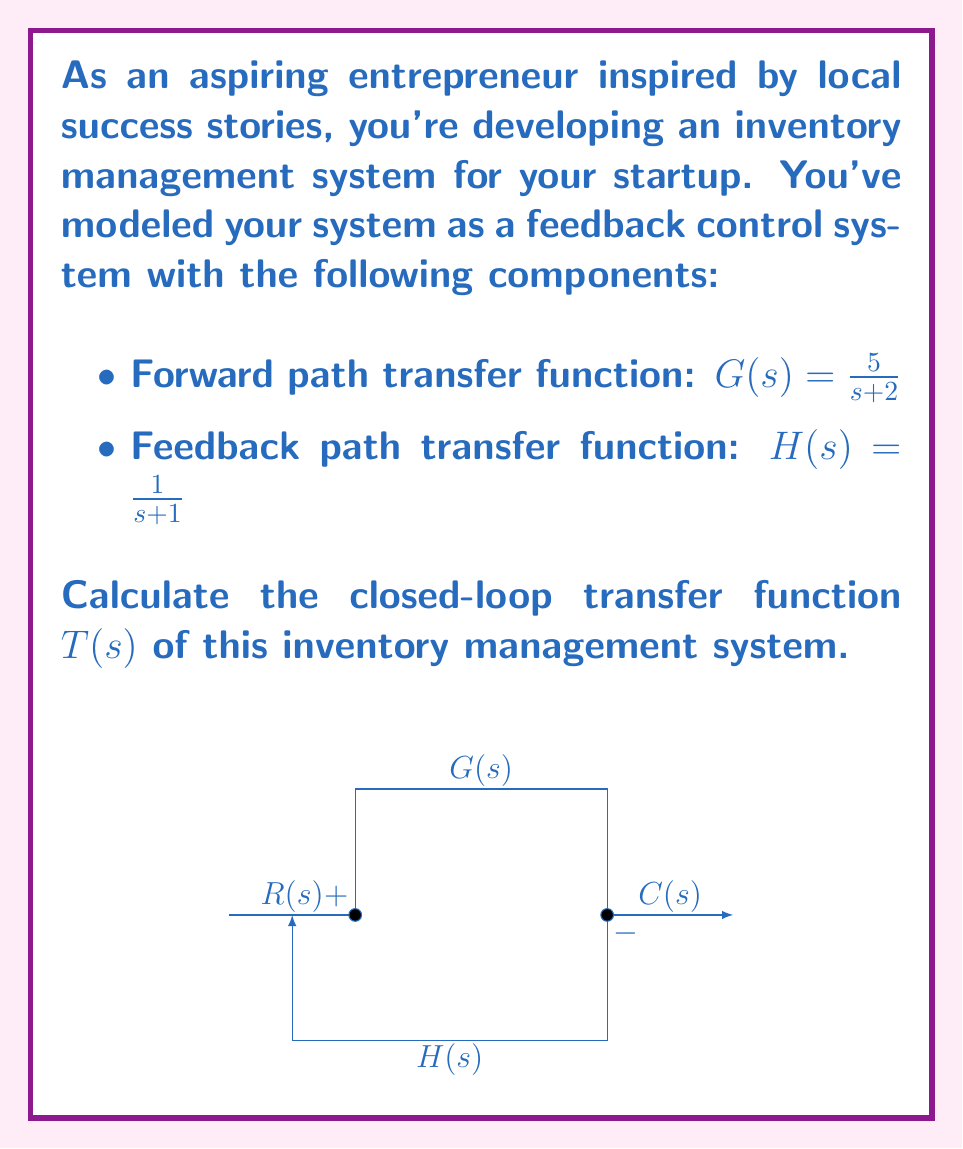Could you help me with this problem? To calculate the closed-loop transfer function of this feedback control system, we'll follow these steps:

1) The general form of a closed-loop transfer function is:

   $$T(s) = \frac{G(s)}{1 + G(s)H(s)}$$

2) We're given:
   $G(s) = \frac{5}{s+2}$
   $H(s) = \frac{1}{s+1}$

3) Let's substitute these into our general form:

   $$T(s) = \frac{\frac{5}{s+2}}{1 + \frac{5}{s+2} \cdot \frac{1}{s+1}}$$

4) To simplify this, let's first multiply the numerator and denominator by $(s+2)(s+1)$:

   $$T(s) = \frac{5(s+1)}{(s+2)(s+1) + 5}$$

5) Expand the denominator:

   $$T(s) = \frac{5(s+1)}{s^2 + 3s + 2 + 5}$$

6) Simplify:

   $$T(s) = \frac{5(s+1)}{s^2 + 3s + 7}$$

7) Expand the numerator:

   $$T(s) = \frac{5s + 5}{s^2 + 3s + 7}$$

This is the closed-loop transfer function of the inventory management system.
Answer: $$T(s) = \frac{5s + 5}{s^2 + 3s + 7}$$ 